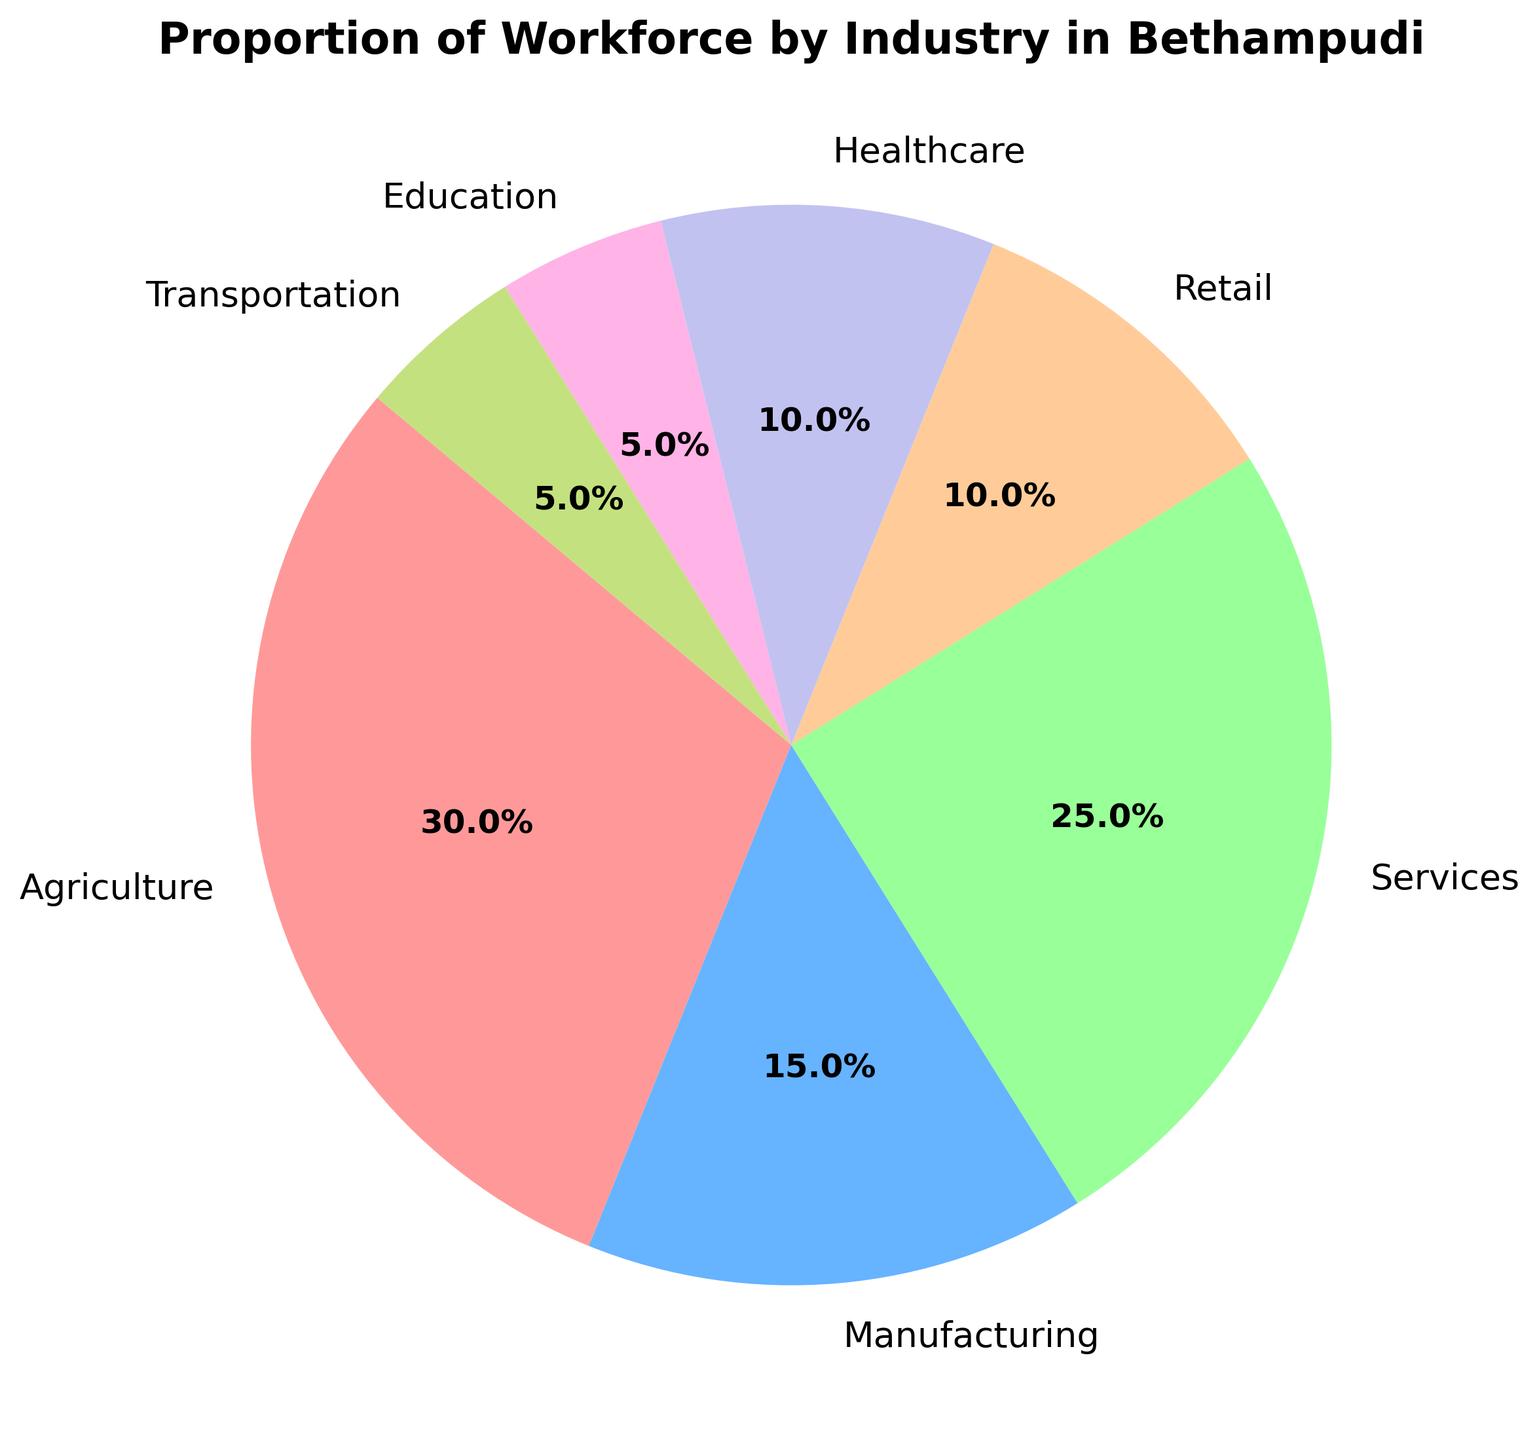Which industry has the largest proportion of the workforce in Bethampudi? By examining the pie chart, it is clear that the largest segment represents the Agriculture sector. The text label indicates that Agriculture comprises 30% of the workforce, which is the largest proportion among all sectors.
Answer: Agriculture What is the combined proportion of the workforce in the Retail and Healthcare industries? To find the combined proportion, sum the individual proportions of the Retail (10%) and Healthcare (10%) sectors. The total combined proportion is 10% + 10%.
Answer: 20% Which industry contributes more to the workforce, Services or Manufacturing, and by how much? According to the pie chart, Services constitute 25% of the workforce whereas Manufacturing accounts for 15%. The difference can be calculated by subtracting Manufacturing's proportion from Services' proportion: 25% - 15%.
Answer: Services, by 10% What percentage of the workforce is engaged in Education, and what is its visual representation on the pie chart? The label on the pie chart shows that Education accounts for 5% of the workforce. Visually, this segment is one of the smaller slices in the chart, colored purple.
Answer: 5% Is the proportion of the Manufacturing workforce larger, smaller, or equal to the combined proportions of Education and Transportation? The Manufacturing sector has a 15% proportion. The combined proportions of Education (5%) and Transportation (5%) sum up to 10%. Since 15% is greater than 10%, Manufacturing has a larger proportion.
Answer: Larger What is the proportion difference between the sector with the second-largest and the one with the third-largest workforce? The Services sector (25%) is the second-largest, and Manufacturing (15%) is the third-largest. The difference is computed by subtracting the Manufacturing proportion from the Services proportion: 25% - 15%.
Answer: 10% How much larger is the proportion of the Agriculture sector compared to the Education sector? Agriculture sector is 30% and Education is 5%. The difference is calculated by subtracting Education's proportion from Agriculture's proportion: 30% - 5%.
Answer: 25% What color represents the Retail sector, and what is its proportion? In the pie chart, the Retail sector is colored orange. The corresponding text label indicates that it constitutes 10% of the workforce.
Answer: Orange, 10% Which two sectors have equal proportions, and what percentage do they represent? Both the Healthcare and Transportation sectors have an equal workforce proportion of 10%.
Answer: Healthcare and Transportation, 10% What is the total proportion of the workforce engaged in Transportation, Healthcare, and Education? To determine the total proportion, sum the proportions of Transportation (5%), Healthcare (10%), and Education (5%): 5% + 10% + 5%.
Answer: 20% 